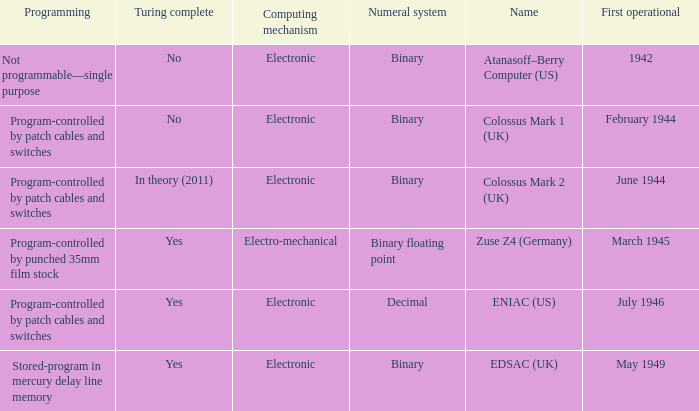What's the turing complete with name being atanasoff–berry computer (us) No. 